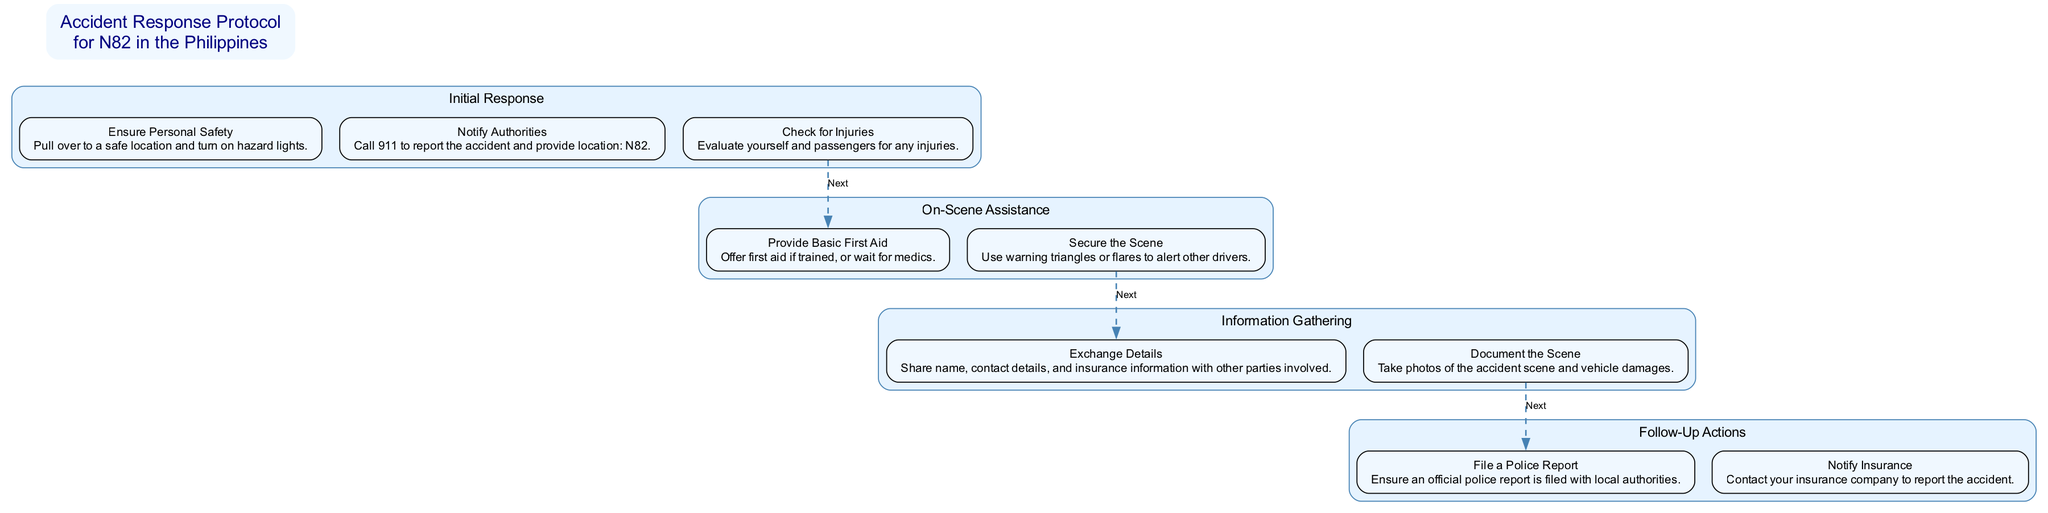What is the first step in the Accident Response Protocol? The first step is "Ensure Personal Safety." It appears at the top of the "Initial Response" category, indicating that it is the first action to take after an accident.
Answer: Ensure Personal Safety How many main categories are in the diagram? There are four main categories: "Initial Response," "On-Scene Assistance," "Information Gathering," and "Follow-Up Actions." You can count these categories in the diagram for a total of four.
Answer: 4 What action should be taken after ensuring personal safety? After ensuring personal safety, the next step is to "Notify Authorities." This follows logically after personal safety is secured as indicated in the diagram flow.
Answer: Notify Authorities What type of assistance can be provided on-scene? The type of assistance is "Basic First Aid." This step is found in the "On-Scene Assistance" category, denoting an immediate action you can take for injured individuals.
Answer: Basic First Aid Which step involves exchanging details with other parties? The step is "Exchange Details." This is found under the "Information Gathering" category and involves sharing necessary information with other drivers involved in the accident.
Answer: Exchange Details What is the last action recommended in the protocol? The last action is "Notify Insurance." It is placed at the bottom of the "Follow-Up Actions" category, indicating it is the final step to be taken after the accident has been reported to authorities.
Answer: Notify Insurance Which category contains the step for securing the accident scene? The step for securing the accident scene is "Secure the Scene," which is in the "On-Scene Assistance" category. This indicates that it is part of providing assistance after the accident.
Answer: On-Scene Assistance What should be done to document the accident scene? You should "Document the Scene," which involves taking photos of the accident and vehicle damages. This step is listed under "Information Gathering."
Answer: Document the Scene How many steps are there in the "Follow-Up Actions" category? There are two steps: "File a Police Report" and "Notify Insurance." You can find these steps in the "Follow-Up Actions" category for a total of two.
Answer: 2 